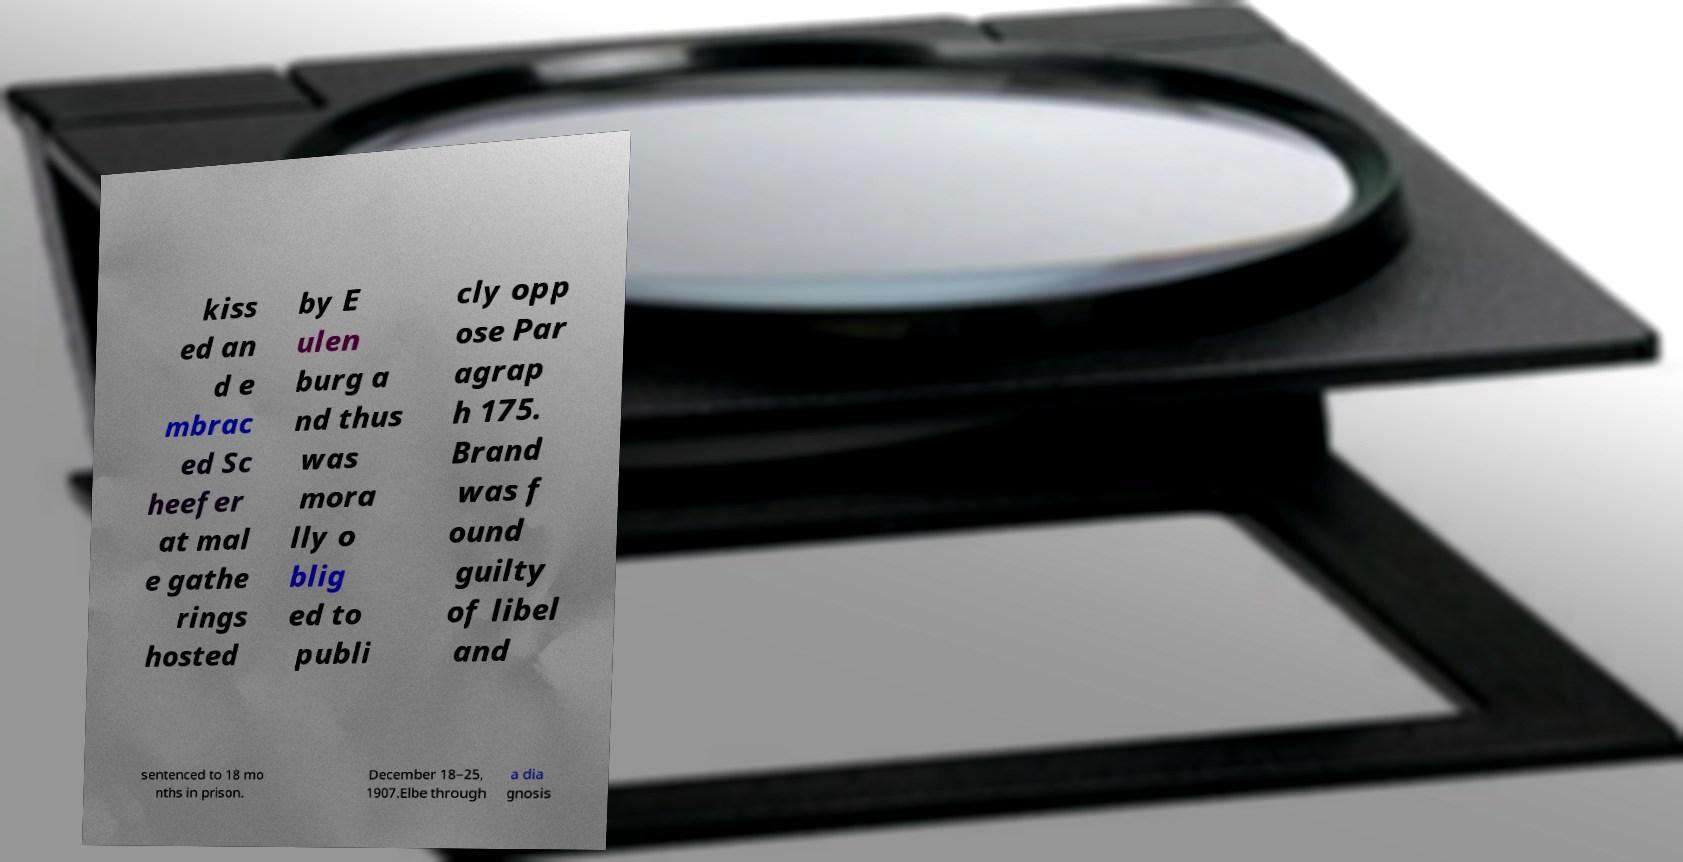Please identify and transcribe the text found in this image. kiss ed an d e mbrac ed Sc heefer at mal e gathe rings hosted by E ulen burg a nd thus was mora lly o blig ed to publi cly opp ose Par agrap h 175. Brand was f ound guilty of libel and sentenced to 18 mo nths in prison. December 18–25, 1907.Elbe through a dia gnosis 